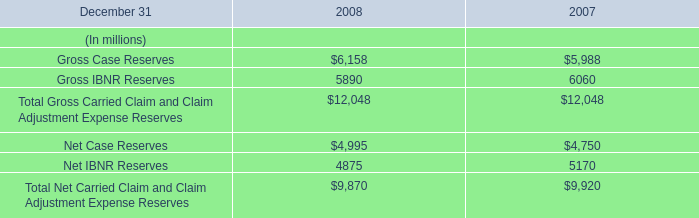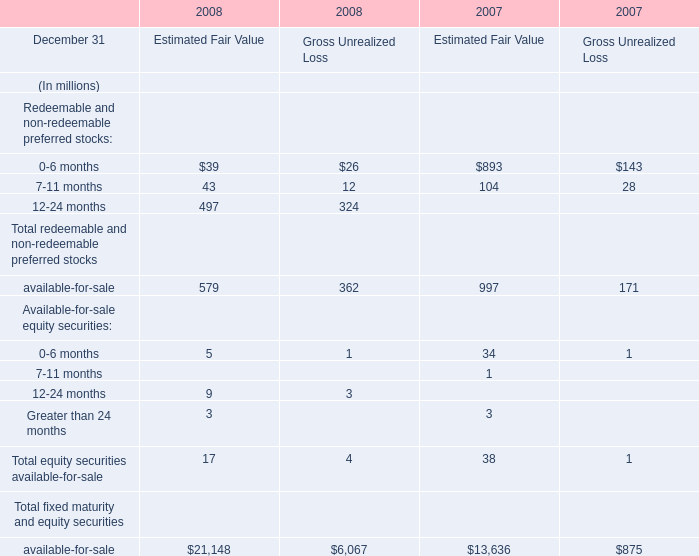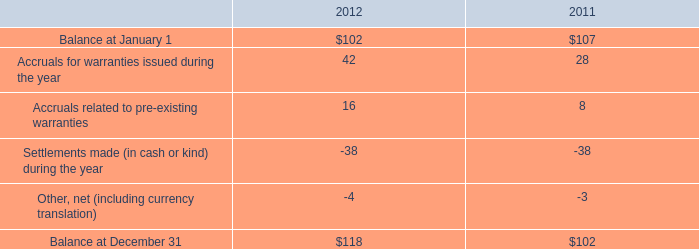What do all elements for Estimated Fair Value sum up in 2008 , excluding available-for-sale and Greater than 24 months? (in million) 
Computations: ((((39 + 43) + 497) + 5) + 9)
Answer: 593.0. 